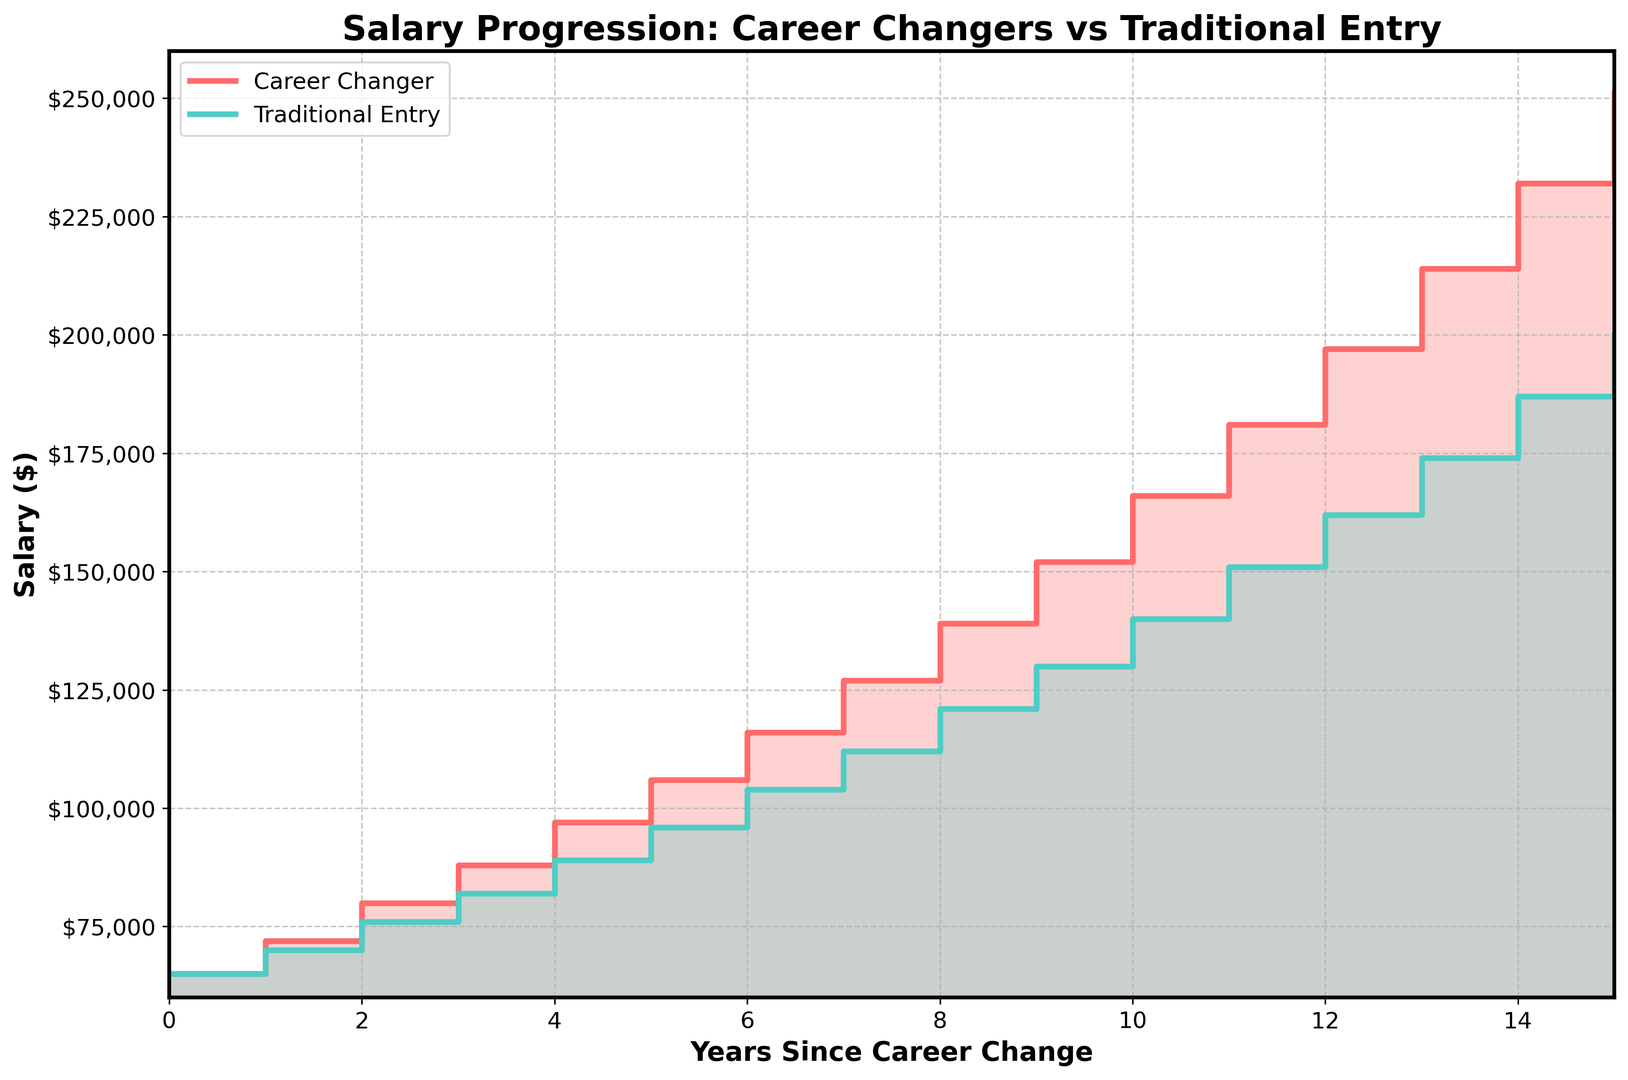what is the salary difference between career changers and traditional entry individuals after 5 years? Find the salary for both career changers ($106,000) and traditional entry individuals ($96,000) at 5 years, then subtract the traditional entry salary from the career changer salary ($106,000 - $96,000).
Answer: $10,000 who has a higher starting salary, career changers or traditional entry individuals? Both career changers and traditional entry individuals start with the same initial salary of $65,000. Compare the starting salaries directly.
Answer: Both are equal by how much does the career changer's salary increase from year 3 to year 4? Find the salary at year 3 ($88,000) and year 4 ($97,000) for career changers, then subtract the year 3 salary from the year 4 salary ($97,000 - $88,000).
Answer: $9,000 at what year does the career changer's salary surpass $200,000? Identify the point where the career changer's salary first exceeds $200,000, which is at year 15 with a salary of $251,000.
Answer: Year 15 what is the total accumulated salary for traditional entry individuals up to year 3? Sum the annual salaries of traditional entry individuals from year 0 to year 3 ($65,000 + $70,000 + $76,000 + $82,000).
Answer: $293,000 which curve (career changers or traditional entry) shows a steeper increase after 8 years? Compare the slope of the salary progression for career changers and traditional entry individuals after 8 years. Career changers move from $139,000 at year 8 to $166,000 at year 10, while traditional entry moves from $121,000 at year 8 to $140,000 at year 10. Hence, career changers have a steeper rise.
Answer: Career changers how much more does a career changer earn at year 10 compared to a traditional entry individual? Look at the salaries at year 10 for both career changers ($166,000) and traditional entry individuals ($140,000), then subtract the traditional entry salary from the career changer salary ($166,000 - $140,000).
Answer: $26,000 what is the average annual increment in salary for traditional entry individuals from year 0 to year 4? Sum the annual salary increments for traditional entry individuals from year 0 to year 4 and divide by the number of years ([(70,000-65,000) + (76,000-70,000) + (82,000-76,000) + (89,000-82,000)] / 4).
Answer: $6,000/year 